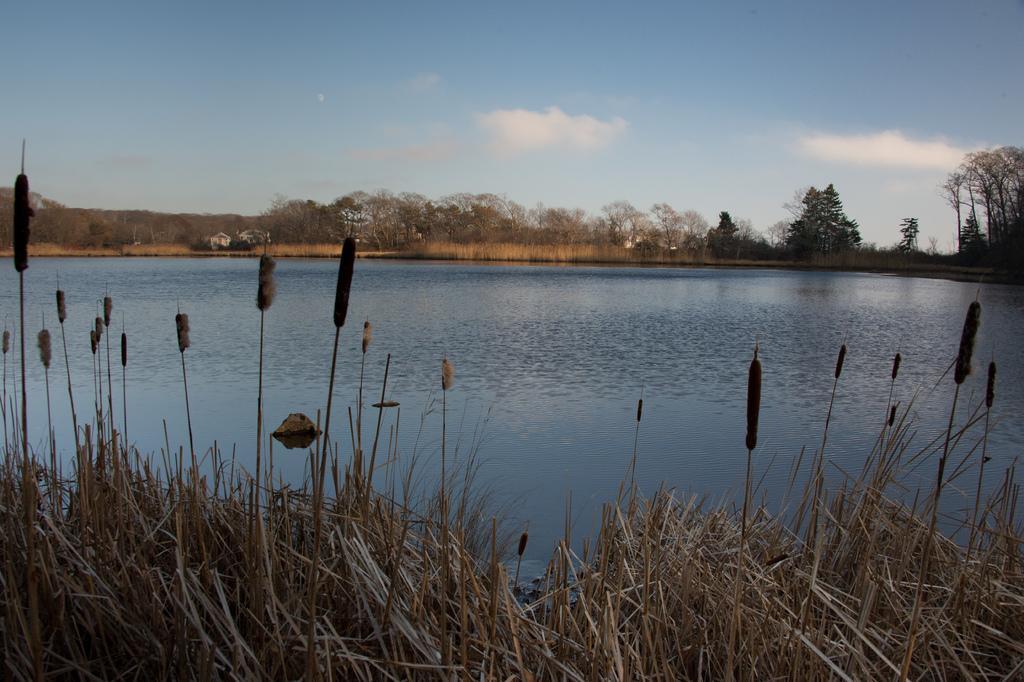Could you give a brief overview of what you see in this image? This is water and in the long back side there are trees. At the top it's a sunny sky. 